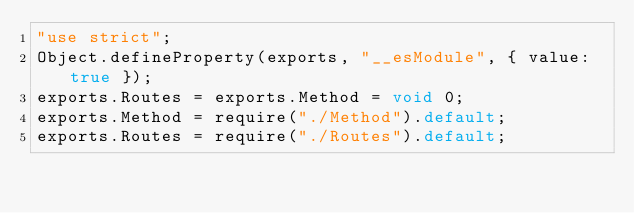<code> <loc_0><loc_0><loc_500><loc_500><_JavaScript_>"use strict";
Object.defineProperty(exports, "__esModule", { value: true });
exports.Routes = exports.Method = void 0;
exports.Method = require("./Method").default;
exports.Routes = require("./Routes").default;
</code> 